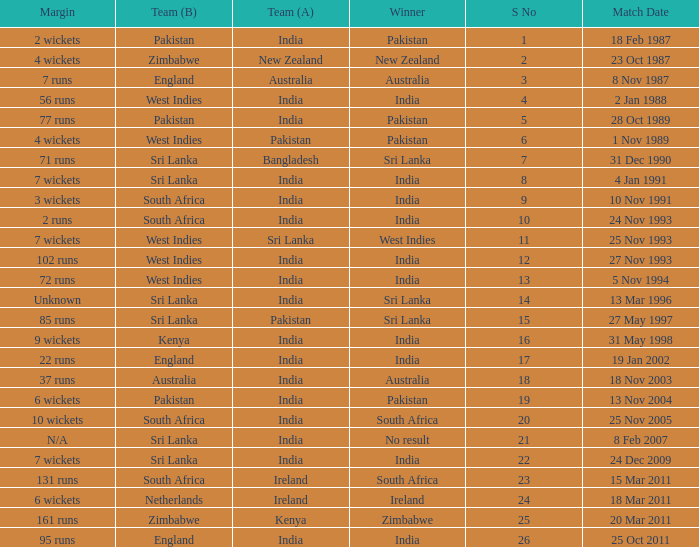What was the margin of the match on 19 Jan 2002? 22 runs. 